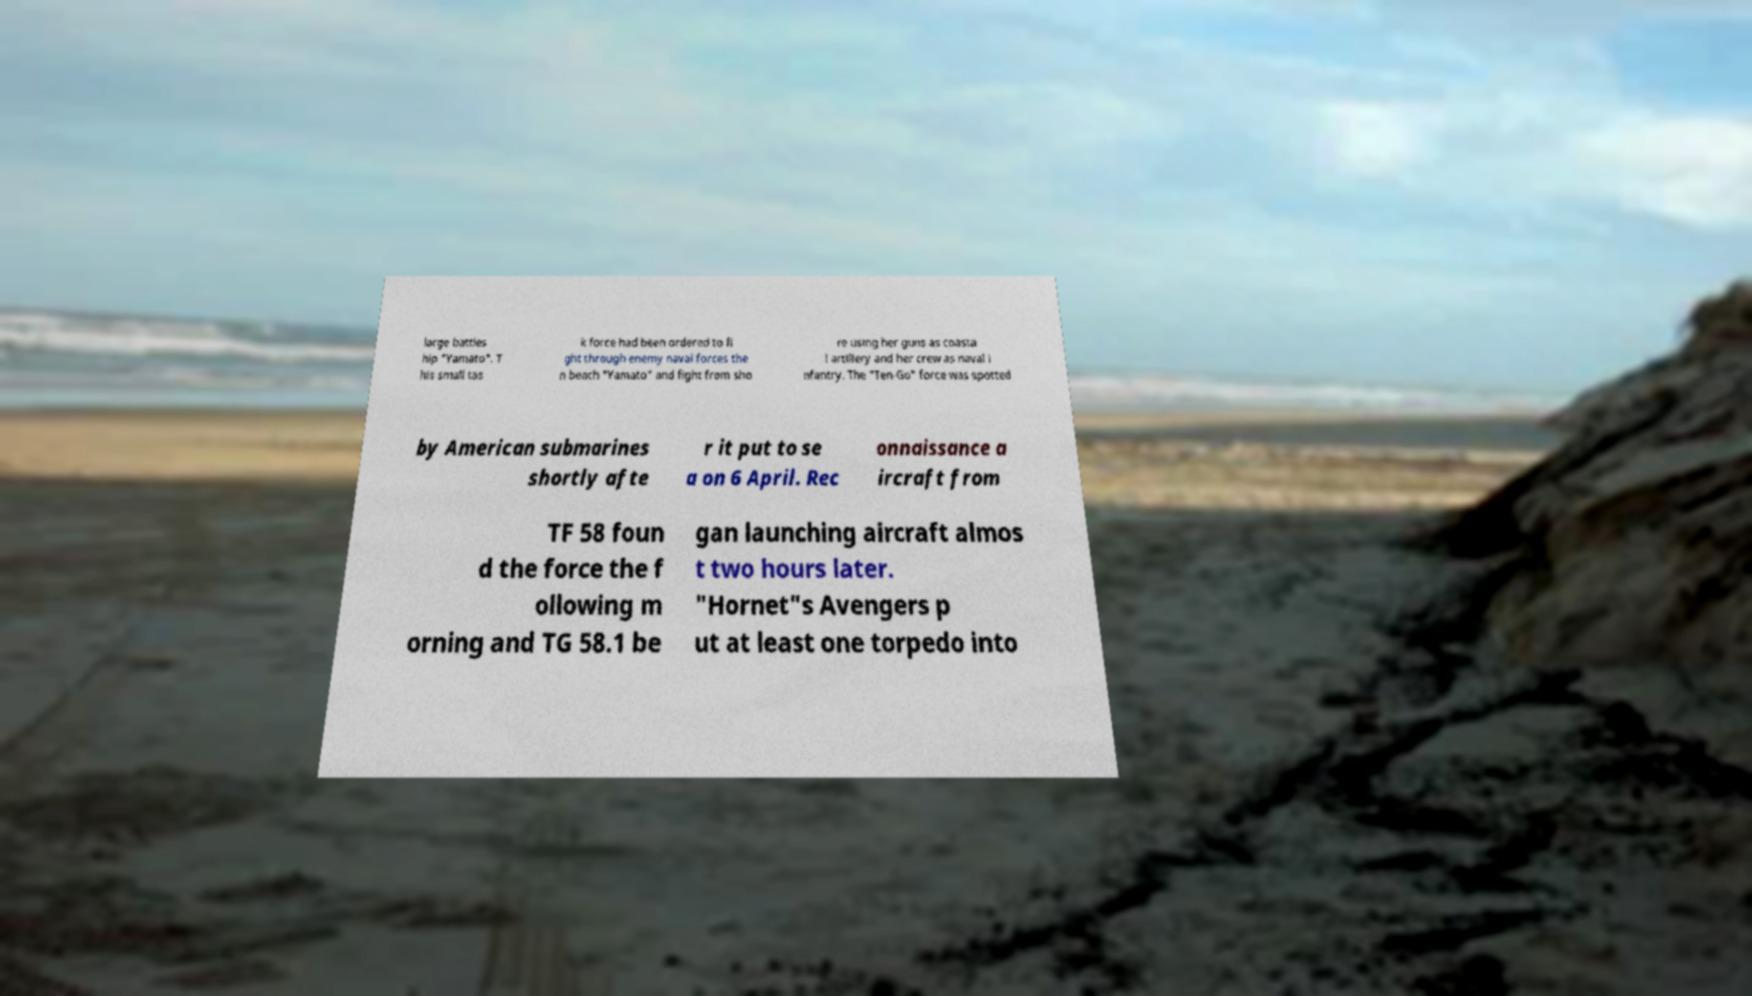Can you read and provide the text displayed in the image?This photo seems to have some interesting text. Can you extract and type it out for me? large battles hip "Yamato". T his small tas k force had been ordered to fi ght through enemy naval forces the n beach "Yamato" and fight from sho re using her guns as coasta l artillery and her crew as naval i nfantry. The "Ten-Go" force was spotted by American submarines shortly afte r it put to se a on 6 April. Rec onnaissance a ircraft from TF 58 foun d the force the f ollowing m orning and TG 58.1 be gan launching aircraft almos t two hours later. "Hornet"s Avengers p ut at least one torpedo into 